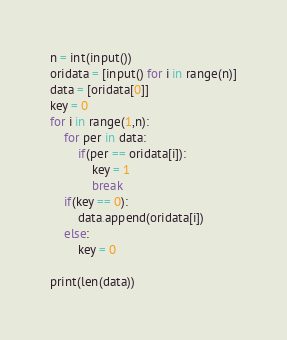<code> <loc_0><loc_0><loc_500><loc_500><_Python_>n = int(input())
oridata = [input() for i in range(n)]
data = [oridata[0]]
key = 0
for i in range(1,n):
    for per in data:
        if(per == oridata[i]):
            key = 1
            break
    if(key == 0):
        data.append(oridata[i])
    else:
        key = 0

print(len(data))




</code> 